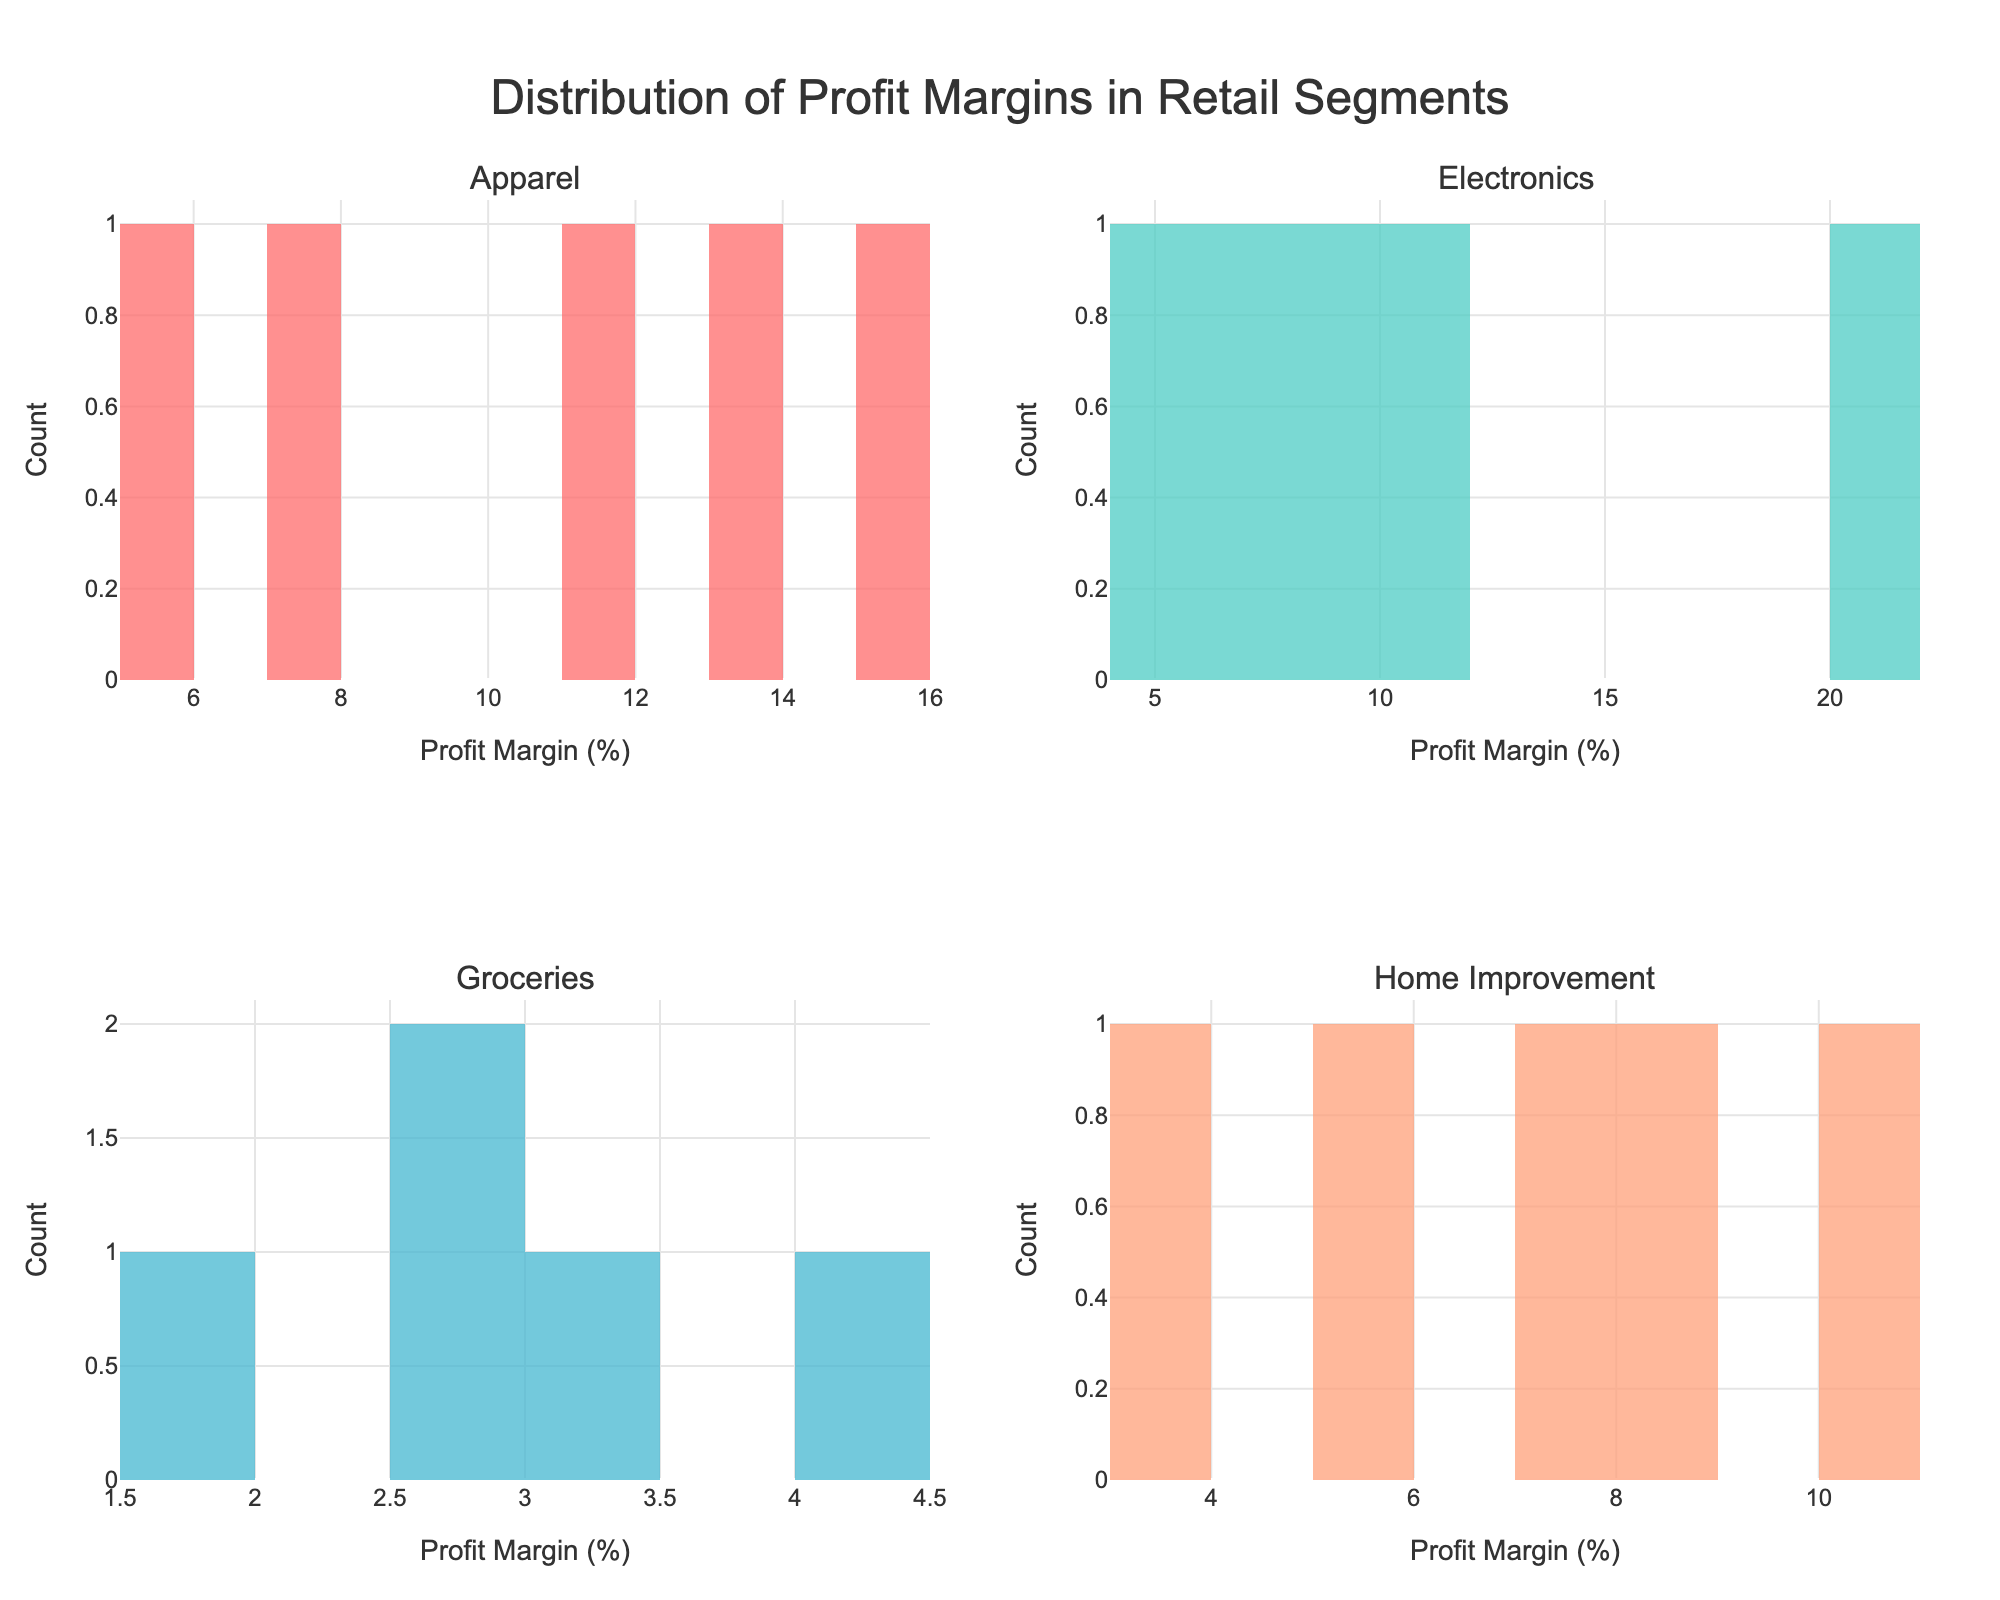Which retail segment has the highest peak in the histogram? The height of each bar in the histogram represents the count of companies with profit margins in that range. The histogram with the highest peak indicates the retail segment with the most companies in a specific profit margin range.
Answer: Groceries Which retail segment shows the widest range of profit margins? The width of the bars in the histogram shows the spread of the profit margins. Segment with the bars covering the widest range on the x-axis displays the largest range of profit margins.
Answer: Electronics What is the most frequent profit margin range for the Apparel segment? Look at the bars in the Apparel histogram and identify the bar with the greatest height. The x-axis label for this bar indicates the most frequent profit margin range.
Answer: 12-14% Which segments have companies with a profit margin over 20%? Identify the histograms and bars where the profit margin exceeds 20%. Check which retail segments have such bars.
Answer: Electronics How many segments have a maximum profit margin above 15%? Count the histograms which have any bars extending beyond the 15% profit margin mark on the x-axis.
Answer: 2 Are there any segments in which all companies have a profit margin below 10%? Check all the histograms to see if there are any segments where no bars extend beyond the 10% profit margin mark.
Answer: Yes, Groceries Which company has the lowest profit margin in the Electronics segment? Refer to the bars in the Electronics histogram and identify the leftmost bar which represents the lowest profit margin. Check which company corresponds to this value.
Answer: Best Buy How does the distribution of profit margins in the Home Improvement segment compare to that in the Apparel segment? Compare the shape, spread, and peak of the histograms for Home Improvement and Apparel. Note differences in range, most frequent profit margins, and general distribution shape.
Answer: Home Improvement is more evenly spread, Apparel is concentrated around 12-14% What's the average profit margin of the highest peak for the segments? Identify the highest peak (tallest bar) in each histogram, note the middle of the range it represents, then calculate the average of these middle points.
Answer: around 7.5% 